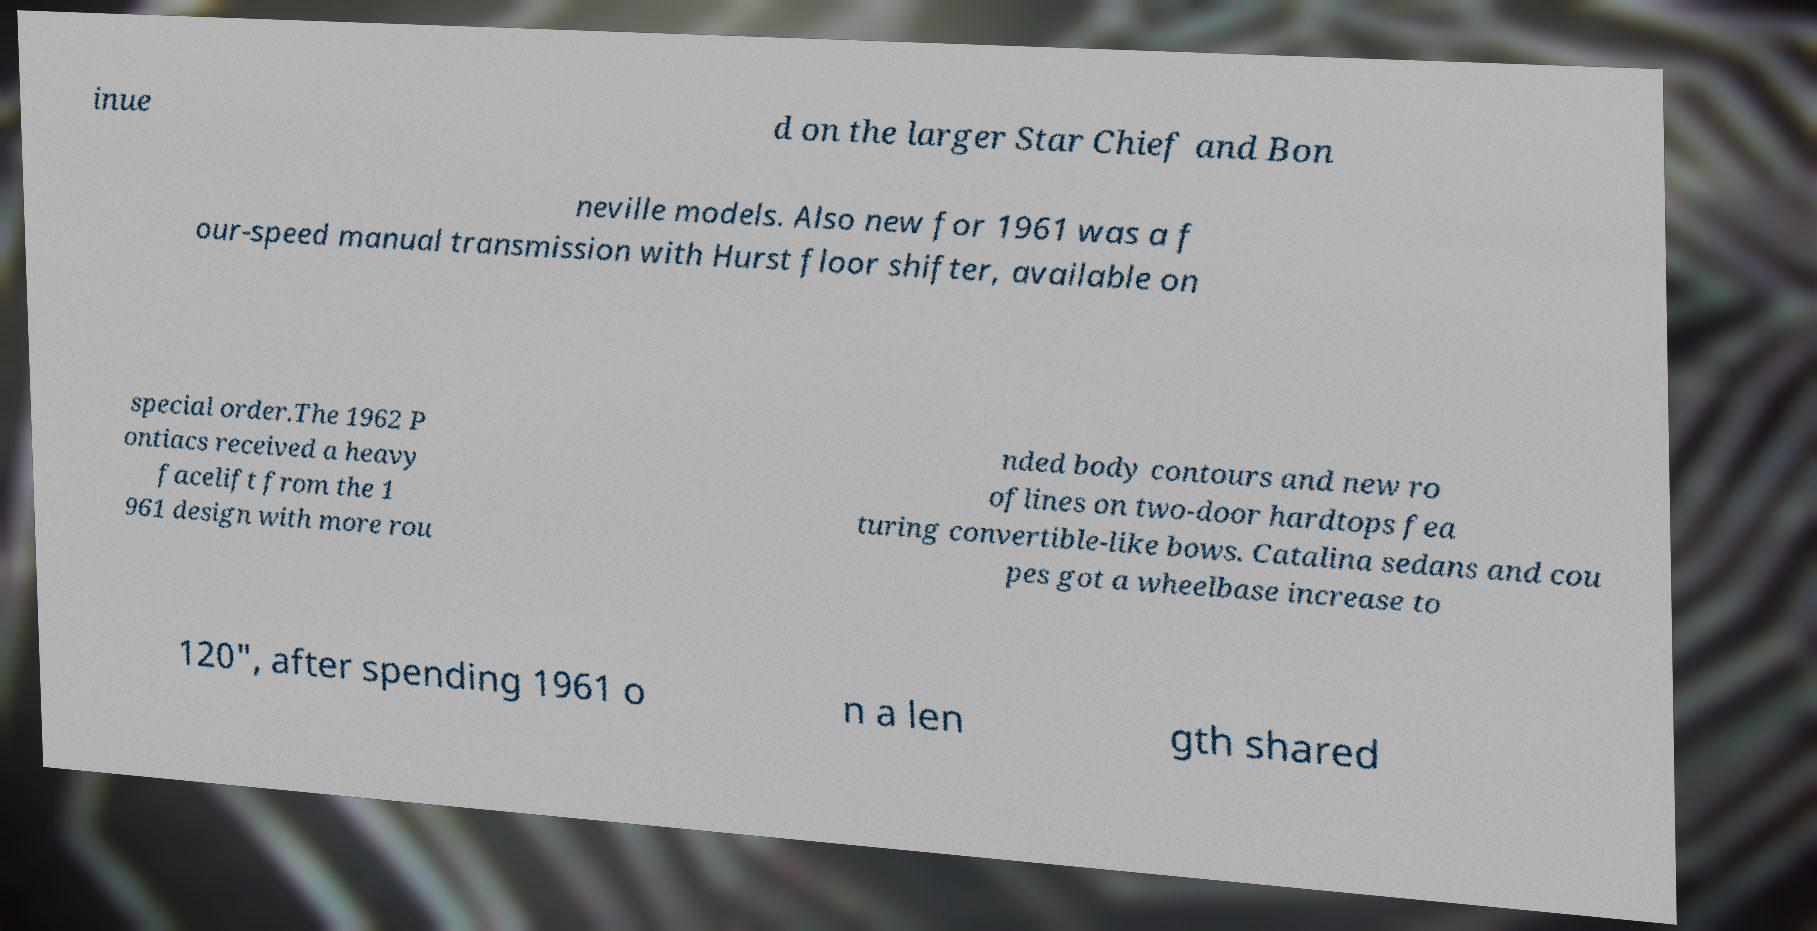Please identify and transcribe the text found in this image. inue d on the larger Star Chief and Bon neville models. Also new for 1961 was a f our-speed manual transmission with Hurst floor shifter, available on special order.The 1962 P ontiacs received a heavy facelift from the 1 961 design with more rou nded body contours and new ro oflines on two-door hardtops fea turing convertible-like bows. Catalina sedans and cou pes got a wheelbase increase to 120", after spending 1961 o n a len gth shared 